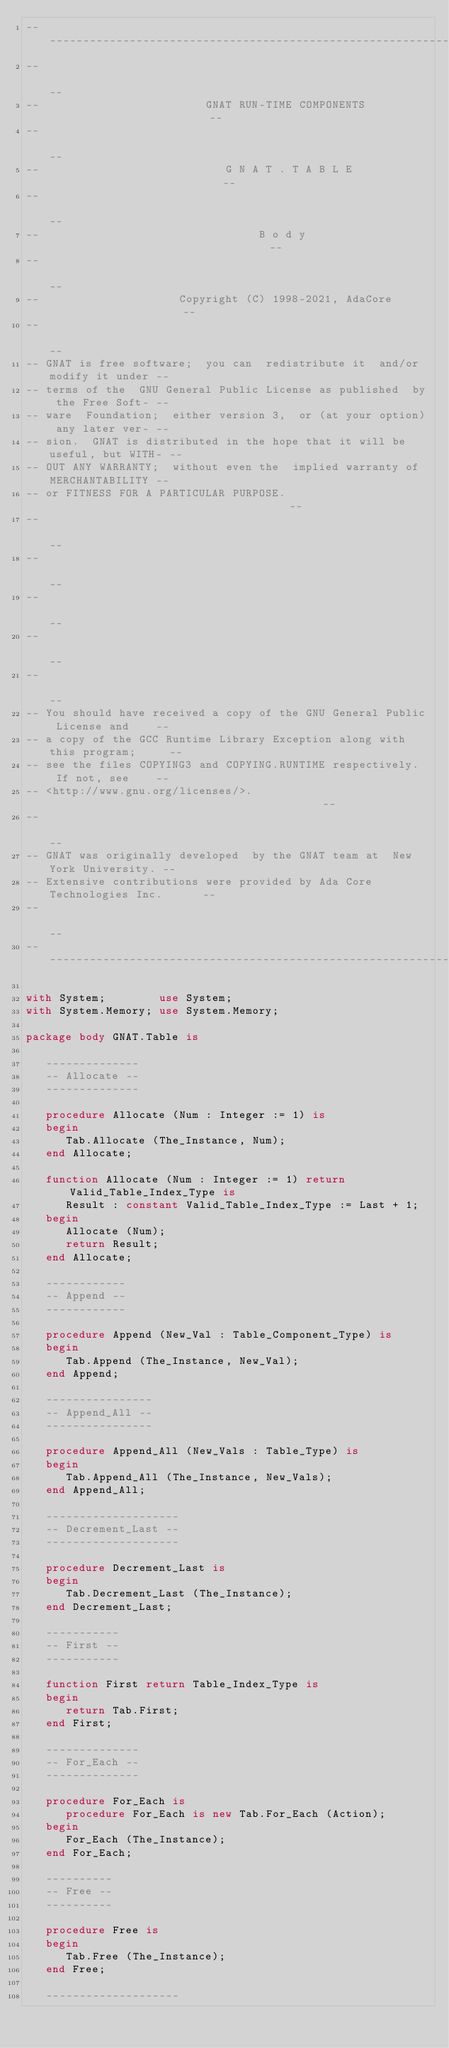<code> <loc_0><loc_0><loc_500><loc_500><_Ada_>------------------------------------------------------------------------------
--                                                                          --
--                         GNAT RUN-TIME COMPONENTS                         --
--                                                                          --
--                            G N A T . T A B L E                           --
--                                                                          --
--                                 B o d y                                  --
--                                                                          --
--                     Copyright (C) 1998-2021, AdaCore                     --
--                                                                          --
-- GNAT is free software;  you can  redistribute it  and/or modify it under --
-- terms of the  GNU General Public License as published  by the Free Soft- --
-- ware  Foundation;  either version 3,  or (at your option) any later ver- --
-- sion.  GNAT is distributed in the hope that it will be useful, but WITH- --
-- OUT ANY WARRANTY;  without even the  implied warranty of MERCHANTABILITY --
-- or FITNESS FOR A PARTICULAR PURPOSE.                                     --
--                                                                          --
--                                                                          --
--                                                                          --
--                                                                          --
--                                                                          --
-- You should have received a copy of the GNU General Public License and    --
-- a copy of the GCC Runtime Library Exception along with this program;     --
-- see the files COPYING3 and COPYING.RUNTIME respectively.  If not, see    --
-- <http://www.gnu.org/licenses/>.                                          --
--                                                                          --
-- GNAT was originally developed  by the GNAT team at  New York University. --
-- Extensive contributions were provided by Ada Core Technologies Inc.      --
--                                                                          --
------------------------------------------------------------------------------

with System;        use System;
with System.Memory; use System.Memory;

package body GNAT.Table is

   --------------
   -- Allocate --
   --------------

   procedure Allocate (Num : Integer := 1) is
   begin
      Tab.Allocate (The_Instance, Num);
   end Allocate;

   function Allocate (Num : Integer := 1) return Valid_Table_Index_Type is
      Result : constant Valid_Table_Index_Type := Last + 1;
   begin
      Allocate (Num);
      return Result;
   end Allocate;

   ------------
   -- Append --
   ------------

   procedure Append (New_Val : Table_Component_Type) is
   begin
      Tab.Append (The_Instance, New_Val);
   end Append;

   ----------------
   -- Append_All --
   ----------------

   procedure Append_All (New_Vals : Table_Type) is
   begin
      Tab.Append_All (The_Instance, New_Vals);
   end Append_All;

   --------------------
   -- Decrement_Last --
   --------------------

   procedure Decrement_Last is
   begin
      Tab.Decrement_Last (The_Instance);
   end Decrement_Last;

   -----------
   -- First --
   -----------

   function First return Table_Index_Type is
   begin
      return Tab.First;
   end First;

   --------------
   -- For_Each --
   --------------

   procedure For_Each is
      procedure For_Each is new Tab.For_Each (Action);
   begin
      For_Each (The_Instance);
   end For_Each;

   ----------
   -- Free --
   ----------

   procedure Free is
   begin
      Tab.Free (The_Instance);
   end Free;

   --------------------</code> 